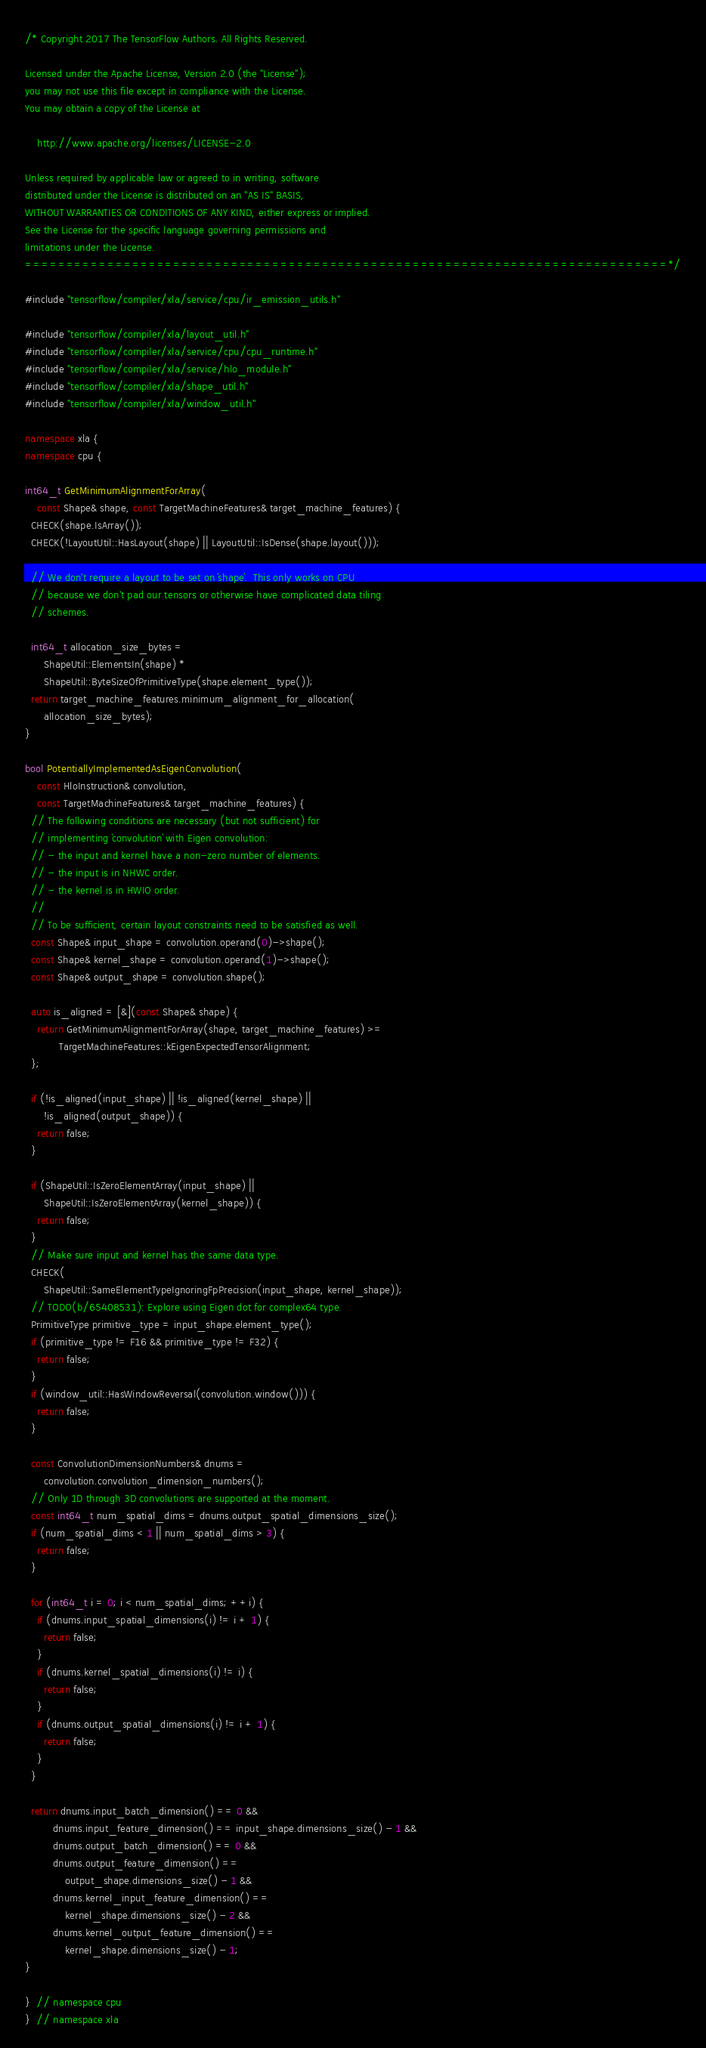Convert code to text. <code><loc_0><loc_0><loc_500><loc_500><_C++_>/* Copyright 2017 The TensorFlow Authors. All Rights Reserved.

Licensed under the Apache License, Version 2.0 (the "License");
you may not use this file except in compliance with the License.
You may obtain a copy of the License at

    http://www.apache.org/licenses/LICENSE-2.0

Unless required by applicable law or agreed to in writing, software
distributed under the License is distributed on an "AS IS" BASIS,
WITHOUT WARRANTIES OR CONDITIONS OF ANY KIND, either express or implied.
See the License for the specific language governing permissions and
limitations under the License.
==============================================================================*/

#include "tensorflow/compiler/xla/service/cpu/ir_emission_utils.h"

#include "tensorflow/compiler/xla/layout_util.h"
#include "tensorflow/compiler/xla/service/cpu/cpu_runtime.h"
#include "tensorflow/compiler/xla/service/hlo_module.h"
#include "tensorflow/compiler/xla/shape_util.h"
#include "tensorflow/compiler/xla/window_util.h"

namespace xla {
namespace cpu {

int64_t GetMinimumAlignmentForArray(
    const Shape& shape, const TargetMachineFeatures& target_machine_features) {
  CHECK(shape.IsArray());
  CHECK(!LayoutUtil::HasLayout(shape) || LayoutUtil::IsDense(shape.layout()));

  // We don't require a layout to be set on `shape`.  This only works on CPU
  // because we don't pad our tensors or otherwise have complicated data tiling
  // schemes.

  int64_t allocation_size_bytes =
      ShapeUtil::ElementsIn(shape) *
      ShapeUtil::ByteSizeOfPrimitiveType(shape.element_type());
  return target_machine_features.minimum_alignment_for_allocation(
      allocation_size_bytes);
}

bool PotentiallyImplementedAsEigenConvolution(
    const HloInstruction& convolution,
    const TargetMachineFeatures& target_machine_features) {
  // The following conditions are necessary (but not sufficient) for
  // implementing `convolution` with Eigen convolution:
  // - the input and kernel have a non-zero number of elements.
  // - the input is in NHWC order.
  // - the kernel is in HWIO order.
  //
  // To be sufficient, certain layout constraints need to be satisfied as well.
  const Shape& input_shape = convolution.operand(0)->shape();
  const Shape& kernel_shape = convolution.operand(1)->shape();
  const Shape& output_shape = convolution.shape();

  auto is_aligned = [&](const Shape& shape) {
    return GetMinimumAlignmentForArray(shape, target_machine_features) >=
           TargetMachineFeatures::kEigenExpectedTensorAlignment;
  };

  if (!is_aligned(input_shape) || !is_aligned(kernel_shape) ||
      !is_aligned(output_shape)) {
    return false;
  }

  if (ShapeUtil::IsZeroElementArray(input_shape) ||
      ShapeUtil::IsZeroElementArray(kernel_shape)) {
    return false;
  }
  // Make sure input and kernel has the same data type.
  CHECK(
      ShapeUtil::SameElementTypeIgnoringFpPrecision(input_shape, kernel_shape));
  // TODO(b/65408531): Explore using Eigen dot for complex64 type.
  PrimitiveType primitive_type = input_shape.element_type();
  if (primitive_type != F16 && primitive_type != F32) {
    return false;
  }
  if (window_util::HasWindowReversal(convolution.window())) {
    return false;
  }

  const ConvolutionDimensionNumbers& dnums =
      convolution.convolution_dimension_numbers();
  // Only 1D through 3D convolutions are supported at the moment.
  const int64_t num_spatial_dims = dnums.output_spatial_dimensions_size();
  if (num_spatial_dims < 1 || num_spatial_dims > 3) {
    return false;
  }

  for (int64_t i = 0; i < num_spatial_dims; ++i) {
    if (dnums.input_spatial_dimensions(i) != i + 1) {
      return false;
    }
    if (dnums.kernel_spatial_dimensions(i) != i) {
      return false;
    }
    if (dnums.output_spatial_dimensions(i) != i + 1) {
      return false;
    }
  }

  return dnums.input_batch_dimension() == 0 &&
         dnums.input_feature_dimension() == input_shape.dimensions_size() - 1 &&
         dnums.output_batch_dimension() == 0 &&
         dnums.output_feature_dimension() ==
             output_shape.dimensions_size() - 1 &&
         dnums.kernel_input_feature_dimension() ==
             kernel_shape.dimensions_size() - 2 &&
         dnums.kernel_output_feature_dimension() ==
             kernel_shape.dimensions_size() - 1;
}

}  // namespace cpu
}  // namespace xla
</code> 